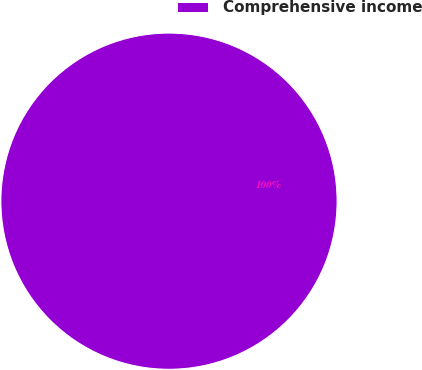Convert chart to OTSL. <chart><loc_0><loc_0><loc_500><loc_500><pie_chart><fcel>Comprehensive income<nl><fcel>100.0%<nl></chart> 